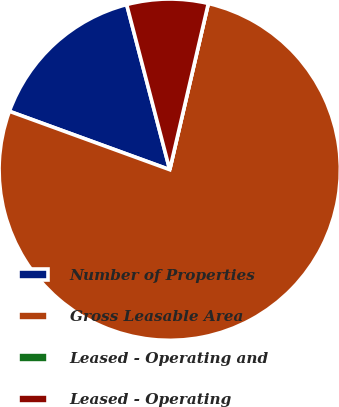Convert chart to OTSL. <chart><loc_0><loc_0><loc_500><loc_500><pie_chart><fcel>Number of Properties<fcel>Gross Leasable Area<fcel>Leased - Operating and<fcel>Leased - Operating<nl><fcel>15.38%<fcel>76.92%<fcel>0.0%<fcel>7.69%<nl></chart> 